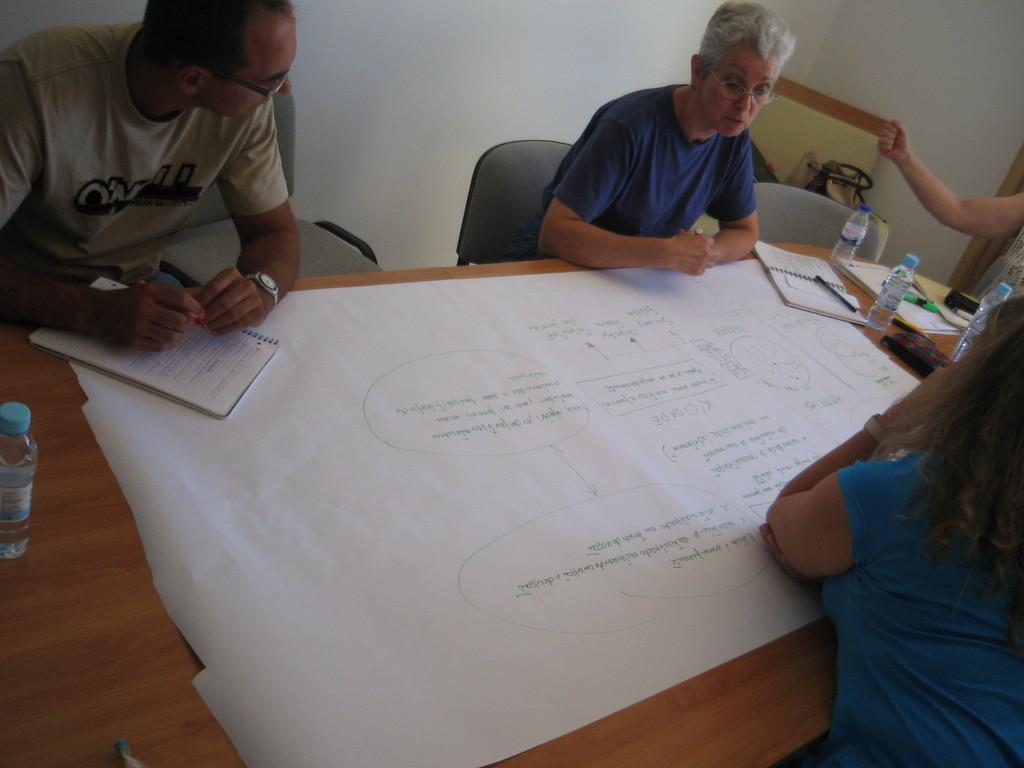How many people are sitting in the image? There are three people sitting on chairs in the image. What objects can be seen on the table? There is a chart, a book, a pen, and a water bottle on the table. What might the people be using to write or draw? The pen on the table might be used by the people for writing or drawing. What type of brass instrument is being played by the people in the image? There is no brass instrument present in the image; the people are simply sitting on chairs. 